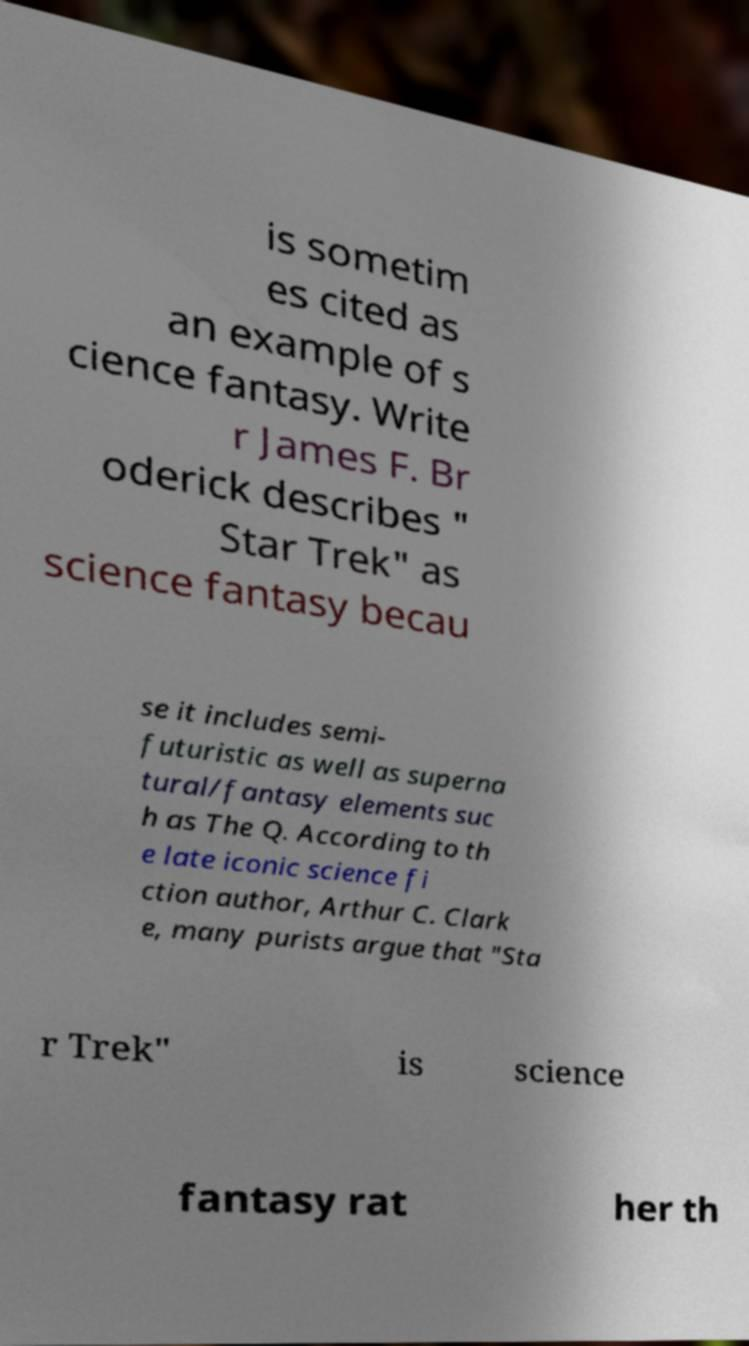Can you read and provide the text displayed in the image?This photo seems to have some interesting text. Can you extract and type it out for me? is sometim es cited as an example of s cience fantasy. Write r James F. Br oderick describes " Star Trek" as science fantasy becau se it includes semi- futuristic as well as superna tural/fantasy elements suc h as The Q. According to th e late iconic science fi ction author, Arthur C. Clark e, many purists argue that "Sta r Trek" is science fantasy rat her th 